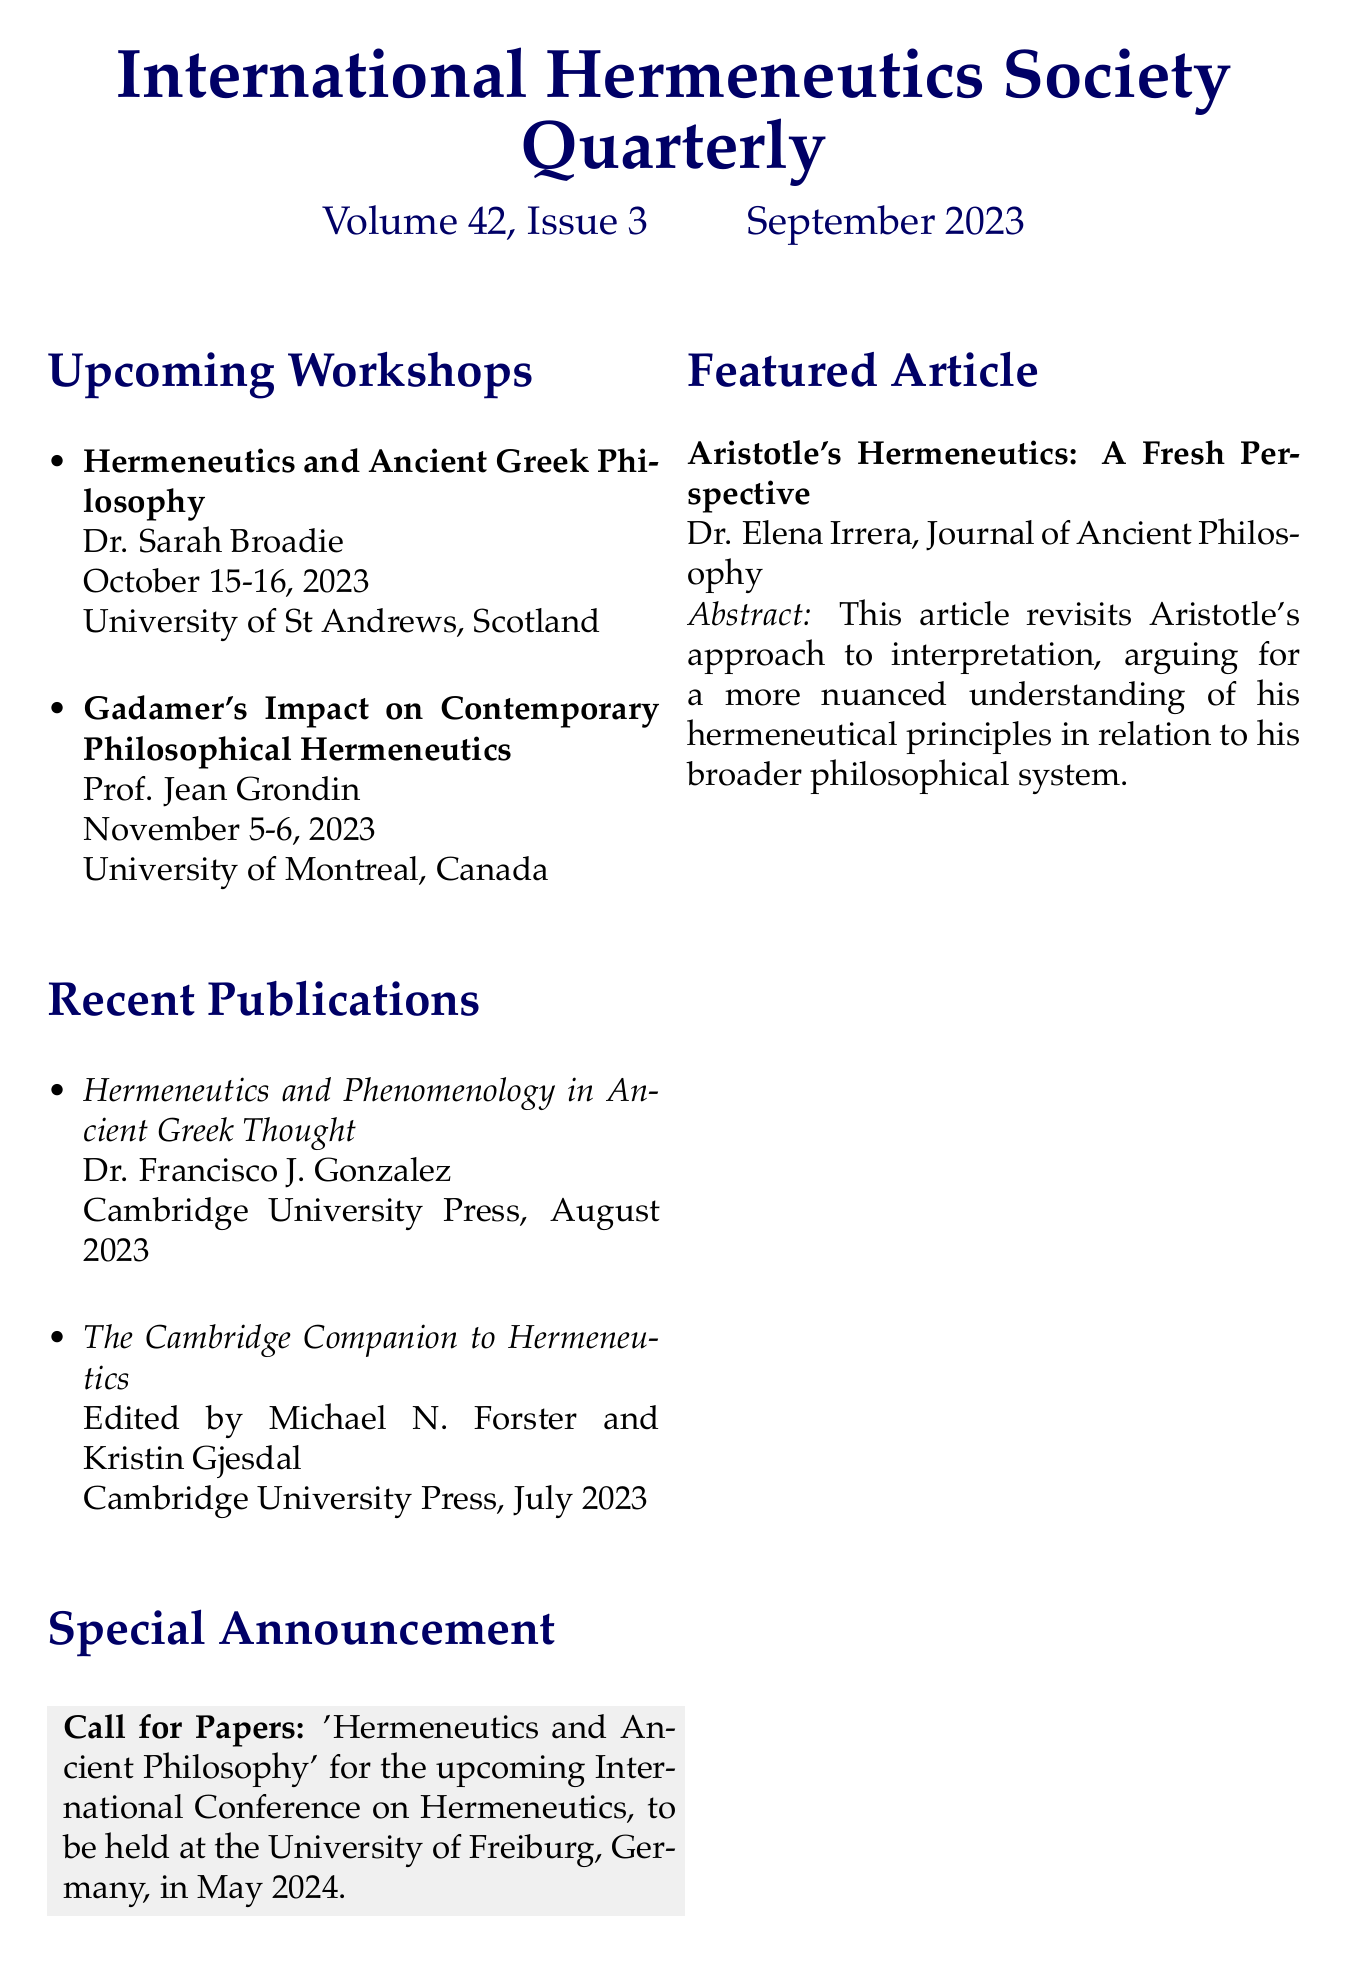What is the title of the featured article? The featured article's title is listed as "Aristotle's Hermeneutics: A Fresh Perspective."
Answer: Aristotle's Hermeneutics: A Fresh Perspective Who is the presenter of the workshop on Gadamer's impact? The document states that Prof. Jean Grondin is the presenter for the workshop titled "Gadamer's Impact on Contemporary Philosophical Hermeneutics."
Answer: Prof. Jean Grondin What is the location of the workshop on Ancient Greek Philosophy? The document specifies that the workshop on Hermeneutics and Ancient Greek Philosophy takes place at the University of St Andrews, Scotland.
Answer: University of St Andrews, Scotland When is the call for papers due? The call for papers is for the upcoming International Conference on Hermeneutics to be held in May 2024.
Answer: May 2024 How many recent publications are listed in the newsletter? There are two recent publications mentioned in the newsletter.
Answer: 2 